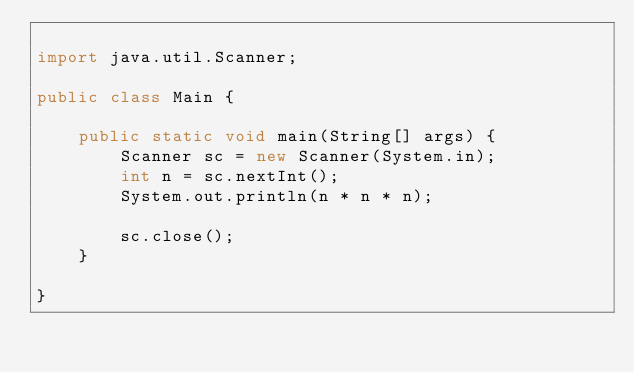Convert code to text. <code><loc_0><loc_0><loc_500><loc_500><_Java_>
import java.util.Scanner;

public class Main {

    public static void main(String[] args) {
        Scanner sc = new Scanner(System.in);
        int n = sc.nextInt();
        System.out.println(n * n * n);

        sc.close();
    }

}
</code> 